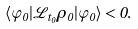<formula> <loc_0><loc_0><loc_500><loc_500>\langle \varphi _ { 0 } | { \mathcal { L } } _ { t _ { 0 } } \rho _ { 0 } | \varphi _ { 0 } \rangle < 0 .</formula> 